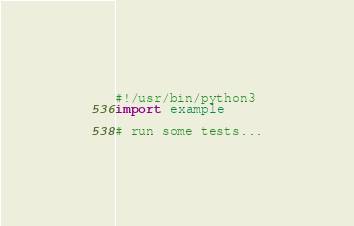Convert code to text. <code><loc_0><loc_0><loc_500><loc_500><_Python_>#!/usr/bin/python3
import example

# run some tests...
</code> 